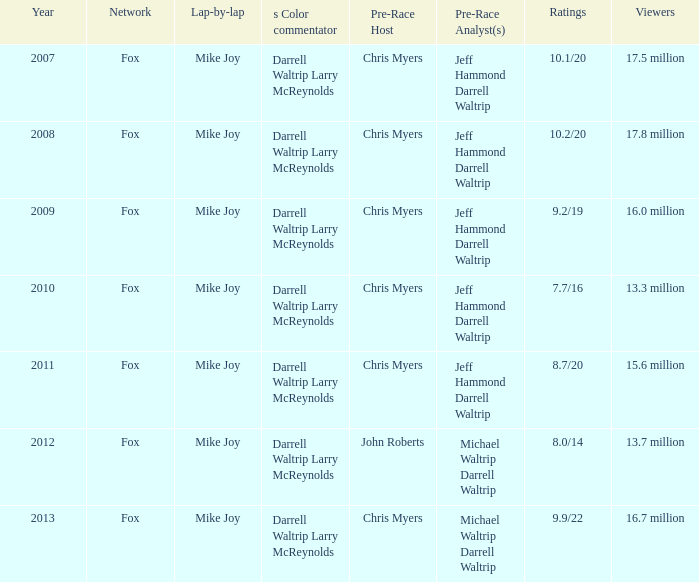Which Network has 16.0 million Viewers? Fox. 